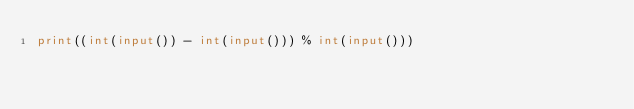Convert code to text. <code><loc_0><loc_0><loc_500><loc_500><_Python_>print((int(input()) - int(input())) % int(input()))</code> 